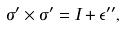Convert formula to latex. <formula><loc_0><loc_0><loc_500><loc_500>\sigma ^ { \prime } \times \sigma ^ { \prime } = I + \epsilon ^ { \prime \prime } ,</formula> 